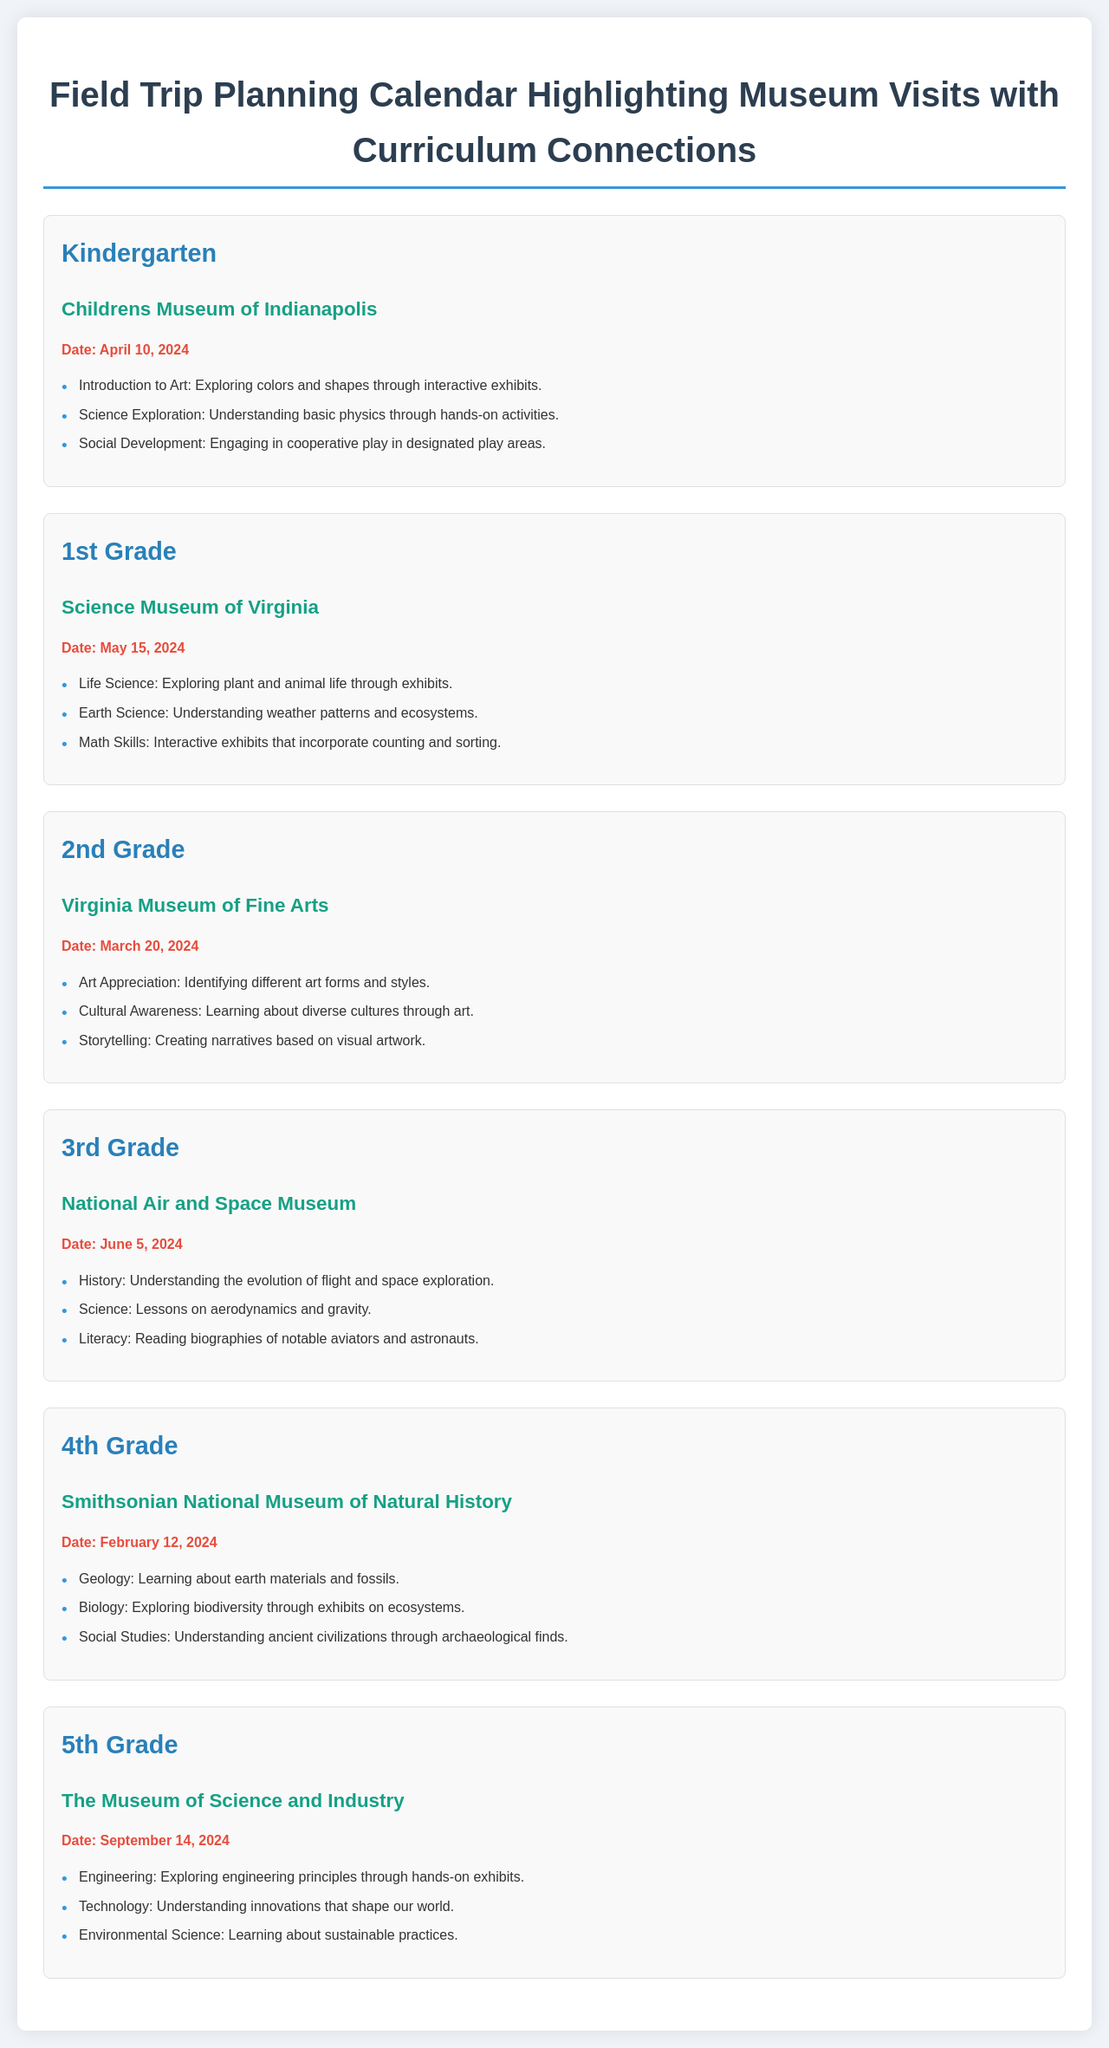What is the date for the Kindergarten visit? The date for the Kindergarten visit is listed under the relevant section in the document for that grade level.
Answer: April 10, 2024 Which museum is visited by 2nd Grade? The museum visited by 2nd Grade is specified in their section and is linked to their curriculum connections.
Answer: Virginia Museum of Fine Arts What subject is focused on during the 5th Grade visit? The subjects for the 5th Grade visit are mentioned along with the museum name and date, indicating the principles explored during their trip.
Answer: Engineering How many curriculum connections are highlighted for 4th Grade? The number of curriculum connections is determined by counting the bullet points provided in the 4th Grade section.
Answer: 3 Which grade is visiting the National Air and Space Museum? This grade correlation can be found by checking the respective section of the document.
Answer: 3rd Grade What is the primary theme for the 1st Grade visit? The primary theme is indicated by the curriculum connections mentioned specifically in the 1st Grade section.
Answer: Life Science Which museum visit is scheduled for February 2024? This can be answered by looking for the date stated in the relevant section.
Answer: Smithsonian National Museum of Natural History What interactive activities are included in the Kindergarten trip? The specific interactive activities can be found in the bullet points listed in the Kindergarten section.
Answer: Exploring colors and shapes through interactive exhibits 